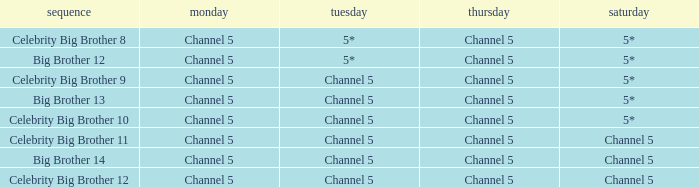Which Tuesday does big brother 12 air? 5*. 